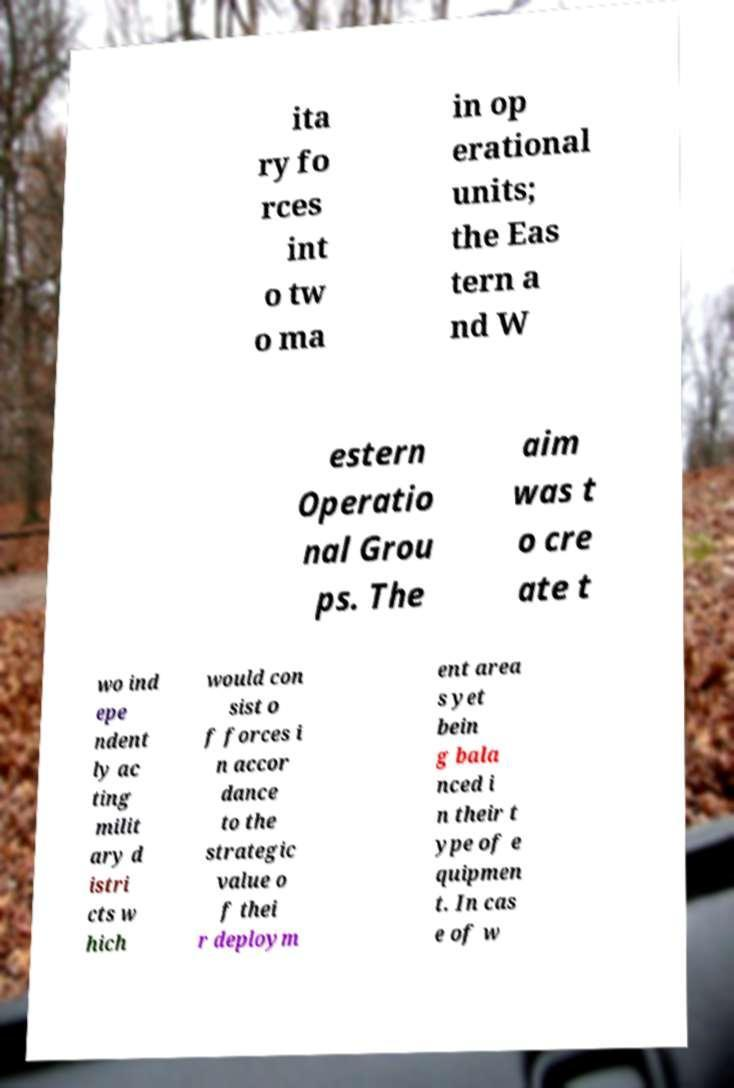Can you accurately transcribe the text from the provided image for me? ita ry fo rces int o tw o ma in op erational units; the Eas tern a nd W estern Operatio nal Grou ps. The aim was t o cre ate t wo ind epe ndent ly ac ting milit ary d istri cts w hich would con sist o f forces i n accor dance to the strategic value o f thei r deploym ent area s yet bein g bala nced i n their t ype of e quipmen t. In cas e of w 